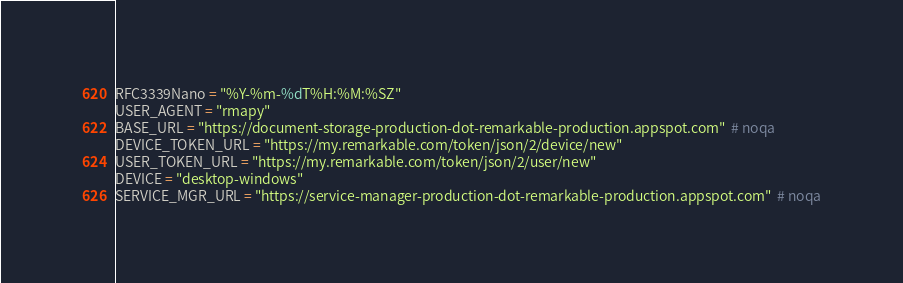Convert code to text. <code><loc_0><loc_0><loc_500><loc_500><_Python_>RFC3339Nano = "%Y-%m-%dT%H:%M:%SZ"
USER_AGENT = "rmapy"
BASE_URL = "https://document-storage-production-dot-remarkable-production.appspot.com"  # noqa
DEVICE_TOKEN_URL = "https://my.remarkable.com/token/json/2/device/new"
USER_TOKEN_URL = "https://my.remarkable.com/token/json/2/user/new"
DEVICE = "desktop-windows"
SERVICE_MGR_URL = "https://service-manager-production-dot-remarkable-production.appspot.com"  # noqa
</code> 